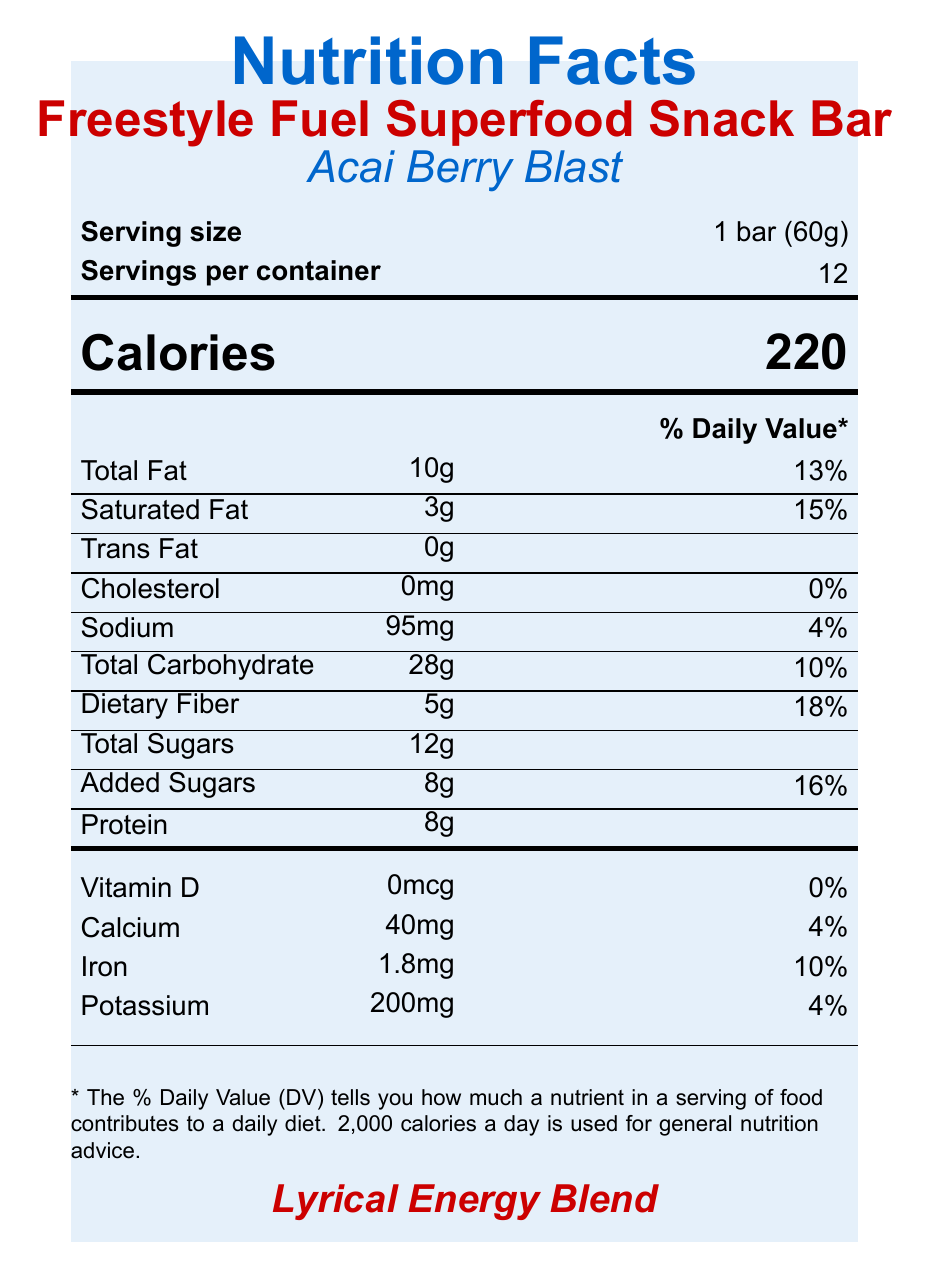what is the serving size for the Freestyle Fuel Superfood Snack Bar? The document states that the serving size is 1 bar (60g) in the serving size information section.
Answer: 1 bar (60g) how many calories are in one serving of the Acai Berry Blast flavor? The document lists Calories as 220 in large text under the Calories section.
Answer: 220 how many milligrams of sodium are in one bar? The sodium content is given as 95mg in the nutrient info section of the document.
Answer: 95mg what is the percentage of daily value for iron in the Freestyle Fuel Superfood Snack Bar? The document shows Iron as 1.8mg with a daily value percentage of 10%.
Answer: 10% is the Freestyle Fuel Superfood Snack Bar vegan? The document includes "Vegan" in the list of claims.
Answer: Yes which of the following ingredients are included in the snack bar? A. Organic almonds B. Organic hemp seeds C. Organic quinoa The ingredients listed include "Organic hemp seeds", but neither "Organic almonds" nor "Organic quinoa" are mentioned.
Answer: B what is the total fat content per serving? A. 15g B. 10g C. 8g The document lists Total Fat as 10g in the nutrient information section.
Answer: B how much protein does one bar of Freestyle Fuel Superfood Snack Bar contain? The protein content is listed as 8g in the nutrient info section.
Answer: 8g does the snack bar contain any added sugars? The document lists Added Sugars as 8g with a 16% daily value.
Answer: Yes does this snack bar contain any trans fat? The Trans Fat content is listed as 0g in the nutrient info section.
Answer: No what are the key attributes of the Freestyle Fuel Superfood Snack Bar? The summary encapsulates the nutritional value, special superfood ingredients, and the claims around the snack bar.
Answer: The Freestyle Fuel Superfood Snack Bar has 220 calories per serving, contains superfoods like acai berry and maca root, and offers nutritional claims such as being vegan, gluten-free, and non-GMO. It provides various vitamins and minerals and is aimed at providing sustained energy and mental clarity. what is the facility's allergen information? The allergen information listed mentions the presence of tree nuts (cashews) and cross-contamination risks.
Answer: The snack bar contains tree nuts (cashews) and is manufactured in a facility that also processes peanuts, other tree nuts, soy, and milk. how many servings are there per container of the Freestyle Fuel Superfood Snack Bar? The servings per container are listed as 12 in the serving size information section.
Answer: 12 what is the purpose of the maca root in the Freestyle Fuel Superfood Snack Bar? The document mentions that maca root is included for sustained energy and mental clarity in the special ingredients section.
Answer: For sustained energy and mental clarity what is the % daily value of calcium per serving? The document lists Calcium as 40mg with a percent daily value of 4%.
Answer: 4% who is the target audience for the Freestyle Fuel Superfood Snack Bar? The document does not explicitly state who the target audience is.
Answer: Not enough information 